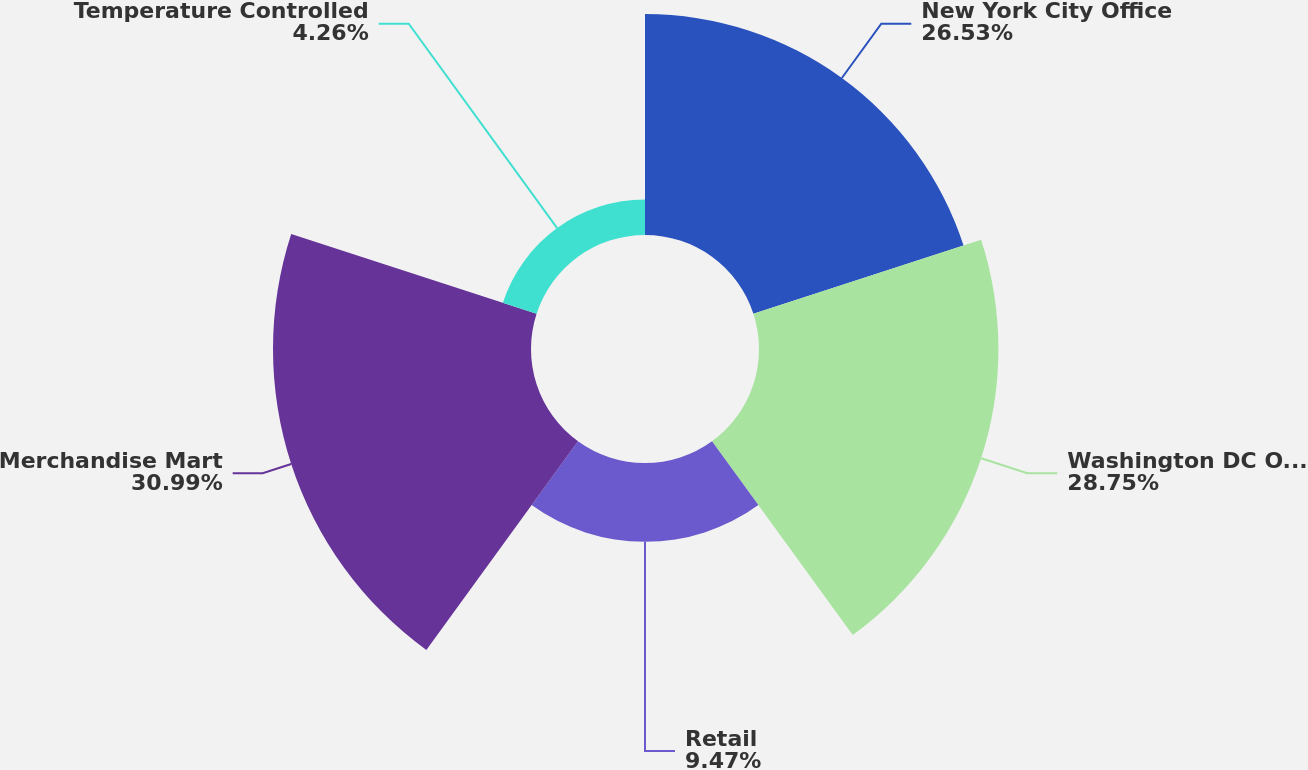<chart> <loc_0><loc_0><loc_500><loc_500><pie_chart><fcel>New York City Office<fcel>Washington DC Office<fcel>Retail<fcel>Merchandise Mart<fcel>Temperature Controlled<nl><fcel>26.53%<fcel>28.75%<fcel>9.47%<fcel>30.98%<fcel>4.26%<nl></chart> 